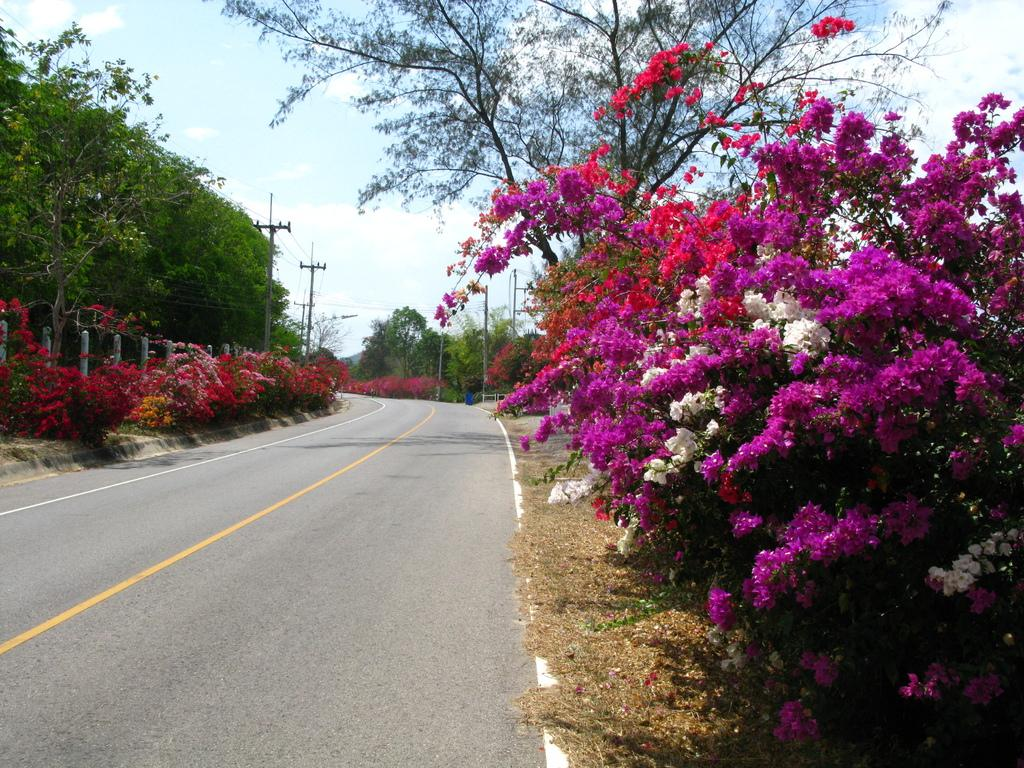What type of vegetation is present on both sides of the image? There are flower trees on both the right and left sides of the image. What is located in the center of the image? There is a road in the center of the image. How many sheep can be seen grazing on the road in the image? There are no sheep present in the image; it features flower trees on both sides and a road in the center. What type of bun is being served at the flower trees in the image? There is no bun present in the image; it only features flower trees and a road. 